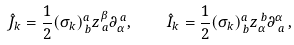<formula> <loc_0><loc_0><loc_500><loc_500>\hat { J } _ { k } = \frac { 1 } { 2 } ( \sigma _ { k } ) _ { \, b } ^ { a } z _ { \, a } ^ { \beta } \partial _ { \alpha } ^ { \, a } , \quad \hat { I } _ { k } = \frac { 1 } { 2 } ( \sigma _ { k } ) _ { \, b } ^ { a } z _ { \alpha } ^ { \, b } \partial _ { \, a } ^ { \alpha } \, ,</formula> 